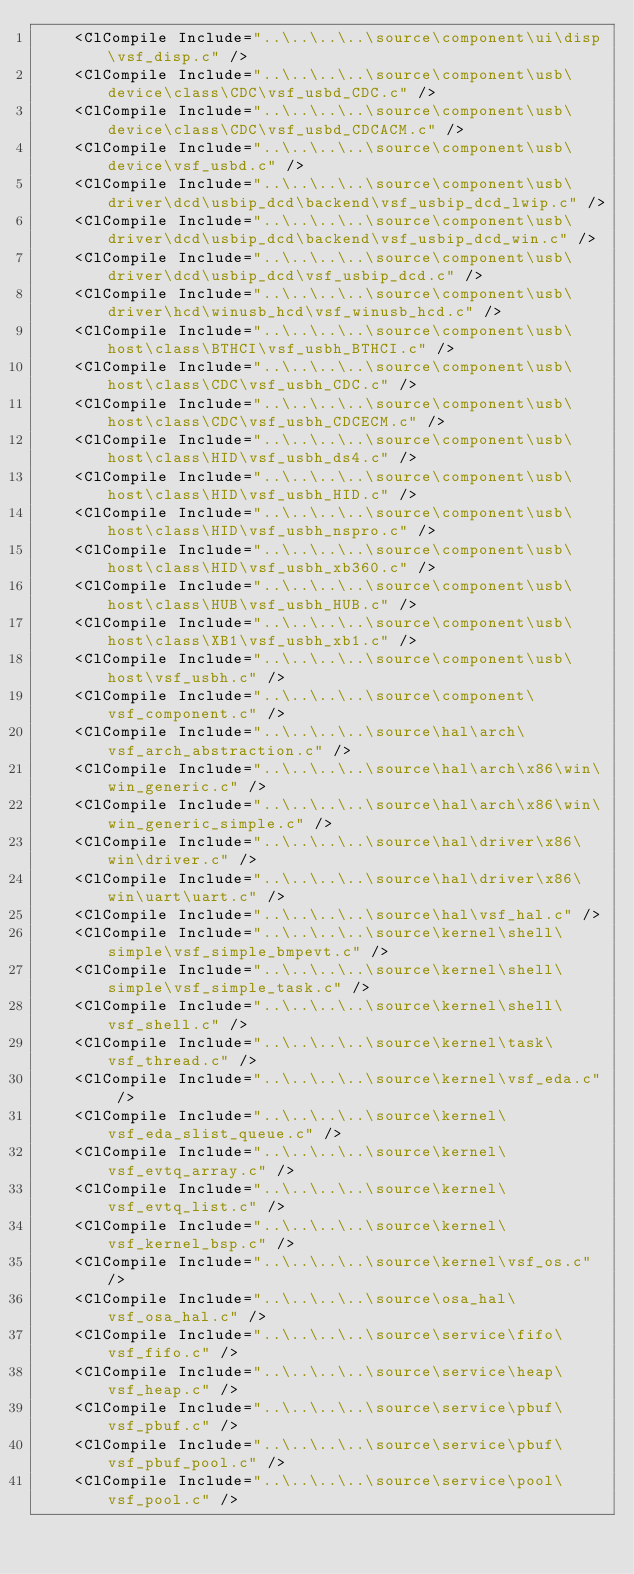<code> <loc_0><loc_0><loc_500><loc_500><_XML_>    <ClCompile Include="..\..\..\..\source\component\ui\disp\vsf_disp.c" />
    <ClCompile Include="..\..\..\..\source\component\usb\device\class\CDC\vsf_usbd_CDC.c" />
    <ClCompile Include="..\..\..\..\source\component\usb\device\class\CDC\vsf_usbd_CDCACM.c" />
    <ClCompile Include="..\..\..\..\source\component\usb\device\vsf_usbd.c" />
    <ClCompile Include="..\..\..\..\source\component\usb\driver\dcd\usbip_dcd\backend\vsf_usbip_dcd_lwip.c" />
    <ClCompile Include="..\..\..\..\source\component\usb\driver\dcd\usbip_dcd\backend\vsf_usbip_dcd_win.c" />
    <ClCompile Include="..\..\..\..\source\component\usb\driver\dcd\usbip_dcd\vsf_usbip_dcd.c" />
    <ClCompile Include="..\..\..\..\source\component\usb\driver\hcd\winusb_hcd\vsf_winusb_hcd.c" />
    <ClCompile Include="..\..\..\..\source\component\usb\host\class\BTHCI\vsf_usbh_BTHCI.c" />
    <ClCompile Include="..\..\..\..\source\component\usb\host\class\CDC\vsf_usbh_CDC.c" />
    <ClCompile Include="..\..\..\..\source\component\usb\host\class\CDC\vsf_usbh_CDCECM.c" />
    <ClCompile Include="..\..\..\..\source\component\usb\host\class\HID\vsf_usbh_ds4.c" />
    <ClCompile Include="..\..\..\..\source\component\usb\host\class\HID\vsf_usbh_HID.c" />
    <ClCompile Include="..\..\..\..\source\component\usb\host\class\HID\vsf_usbh_nspro.c" />
    <ClCompile Include="..\..\..\..\source\component\usb\host\class\HID\vsf_usbh_xb360.c" />
    <ClCompile Include="..\..\..\..\source\component\usb\host\class\HUB\vsf_usbh_HUB.c" />
    <ClCompile Include="..\..\..\..\source\component\usb\host\class\XB1\vsf_usbh_xb1.c" />
    <ClCompile Include="..\..\..\..\source\component\usb\host\vsf_usbh.c" />
    <ClCompile Include="..\..\..\..\source\component\vsf_component.c" />
    <ClCompile Include="..\..\..\..\source\hal\arch\vsf_arch_abstraction.c" />
    <ClCompile Include="..\..\..\..\source\hal\arch\x86\win\win_generic.c" />
    <ClCompile Include="..\..\..\..\source\hal\arch\x86\win\win_generic_simple.c" />
    <ClCompile Include="..\..\..\..\source\hal\driver\x86\win\driver.c" />
    <ClCompile Include="..\..\..\..\source\hal\driver\x86\win\uart\uart.c" />
    <ClCompile Include="..\..\..\..\source\hal\vsf_hal.c" />
    <ClCompile Include="..\..\..\..\source\kernel\shell\simple\vsf_simple_bmpevt.c" />
    <ClCompile Include="..\..\..\..\source\kernel\shell\simple\vsf_simple_task.c" />
    <ClCompile Include="..\..\..\..\source\kernel\shell\vsf_shell.c" />
    <ClCompile Include="..\..\..\..\source\kernel\task\vsf_thread.c" />
    <ClCompile Include="..\..\..\..\source\kernel\vsf_eda.c" />
    <ClCompile Include="..\..\..\..\source\kernel\vsf_eda_slist_queue.c" />
    <ClCompile Include="..\..\..\..\source\kernel\vsf_evtq_array.c" />
    <ClCompile Include="..\..\..\..\source\kernel\vsf_evtq_list.c" />
    <ClCompile Include="..\..\..\..\source\kernel\vsf_kernel_bsp.c" />
    <ClCompile Include="..\..\..\..\source\kernel\vsf_os.c" />
    <ClCompile Include="..\..\..\..\source\osa_hal\vsf_osa_hal.c" />
    <ClCompile Include="..\..\..\..\source\service\fifo\vsf_fifo.c" />
    <ClCompile Include="..\..\..\..\source\service\heap\vsf_heap.c" />
    <ClCompile Include="..\..\..\..\source\service\pbuf\vsf_pbuf.c" />
    <ClCompile Include="..\..\..\..\source\service\pbuf\vsf_pbuf_pool.c" />
    <ClCompile Include="..\..\..\..\source\service\pool\vsf_pool.c" /></code> 